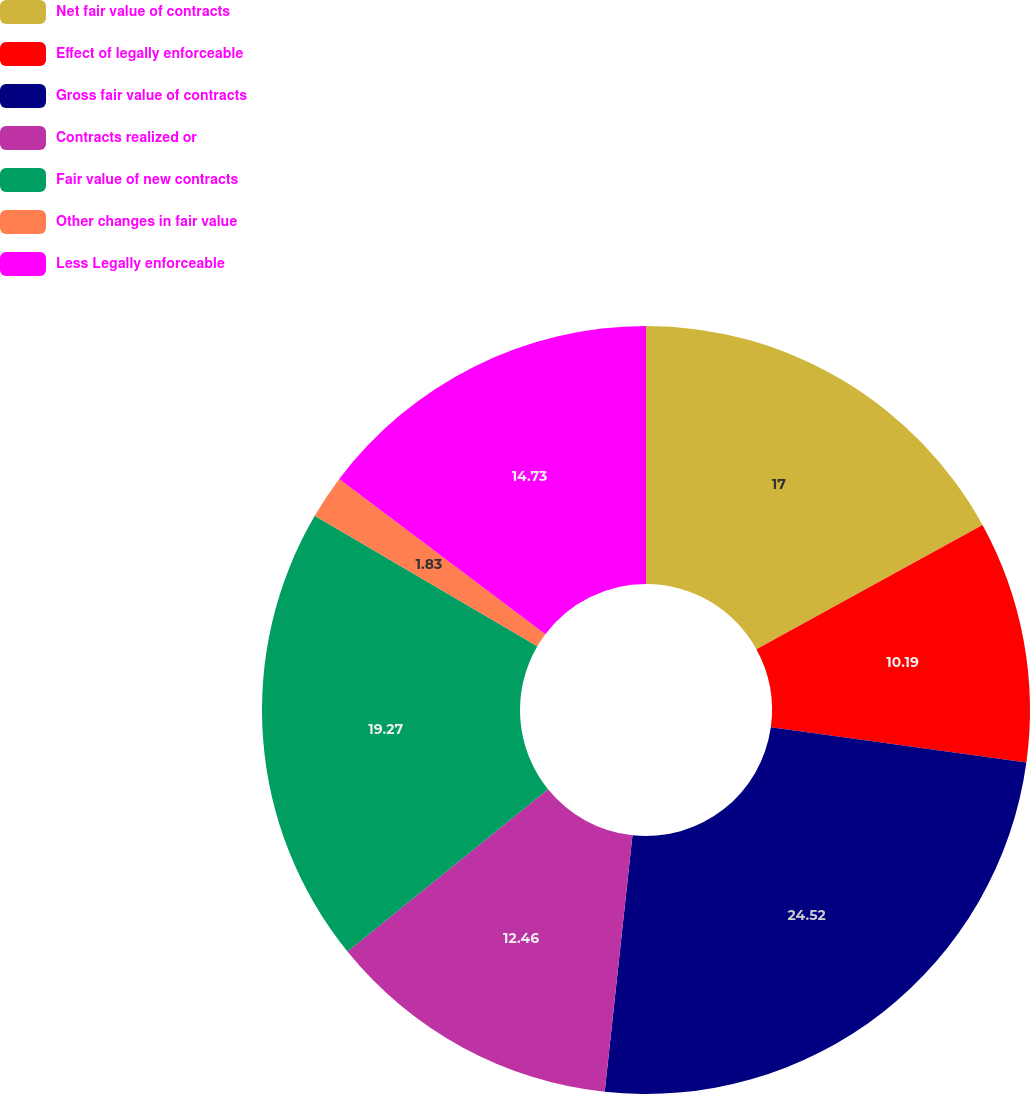Convert chart. <chart><loc_0><loc_0><loc_500><loc_500><pie_chart><fcel>Net fair value of contracts<fcel>Effect of legally enforceable<fcel>Gross fair value of contracts<fcel>Contracts realized or<fcel>Fair value of new contracts<fcel>Other changes in fair value<fcel>Less Legally enforceable<nl><fcel>17.0%<fcel>10.19%<fcel>24.53%<fcel>12.46%<fcel>19.27%<fcel>1.83%<fcel>14.73%<nl></chart> 